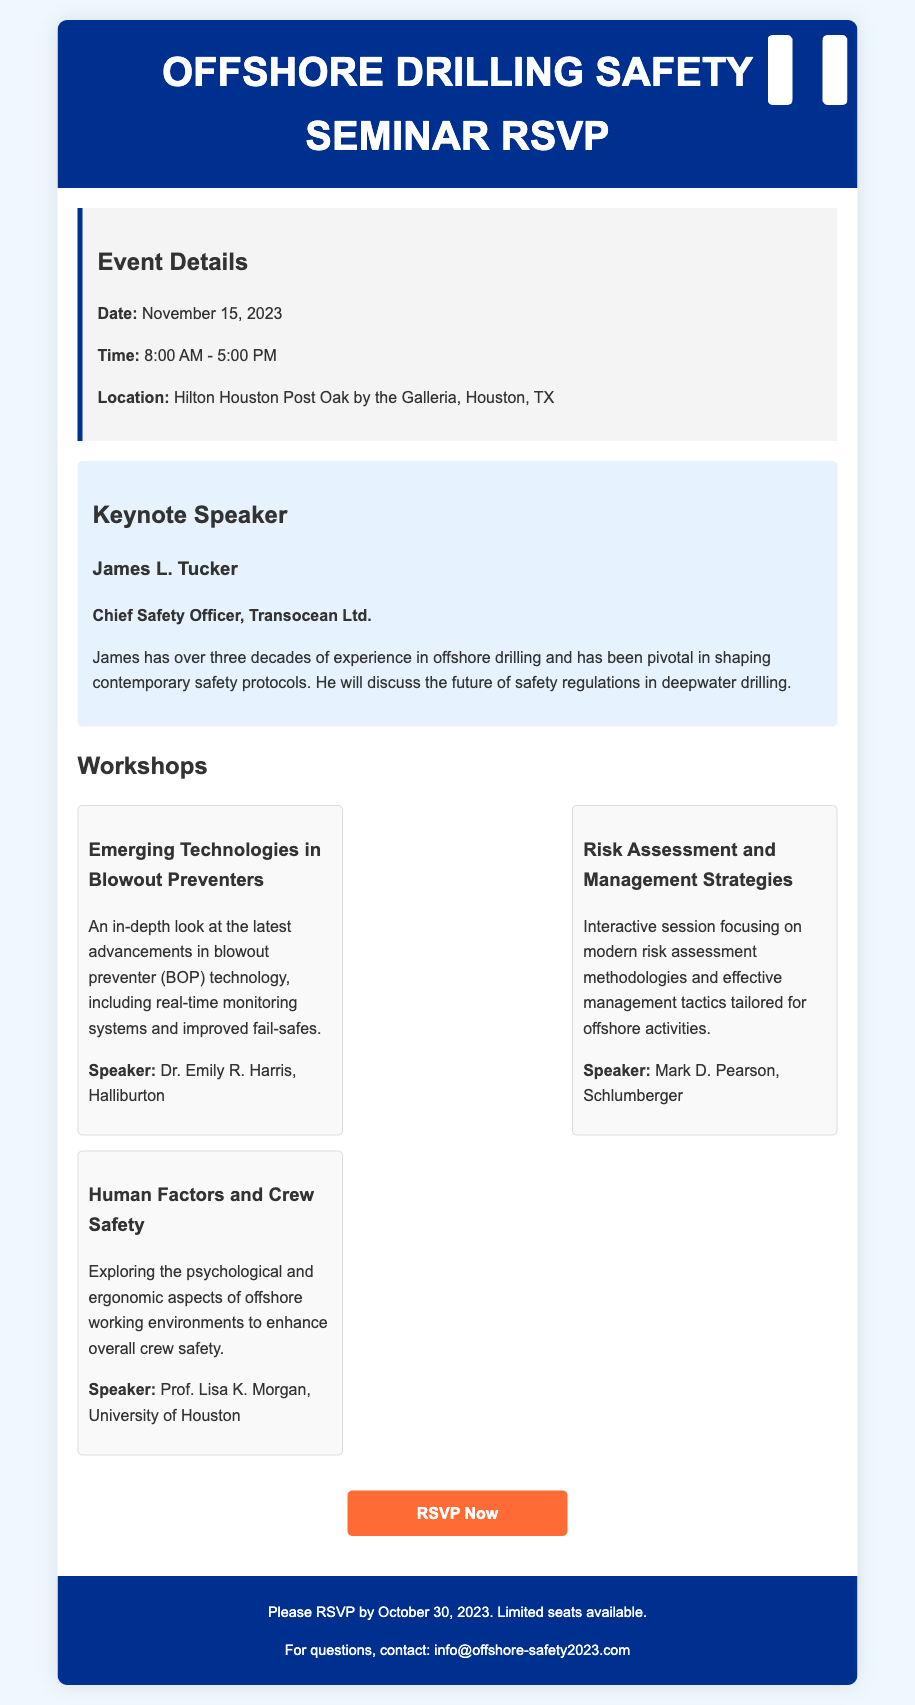What is the date of the seminar? The date of the seminar is explicitly stated in the event details section.
Answer: November 15, 2023 Who is the keynote speaker? The keynote speaker's name is listed under the keynote speaker section.
Answer: James L. Tucker What is James L. Tucker's position? His position is detailed alongside his name in the document.
Answer: Chief Safety Officer, Transocean Ltd How many workshops are listed? The number of workshops can be counted from the workshops section in the document.
Answer: Three What is the title of the workshop led by Dr. Emily R. Harris? The workshop titles are specified within the workshops section.
Answer: Emerging Technologies in Blowout Preventers What time does the seminar start? The starting time is noted in the event details section of the document.
Answer: 8:00 AM What is the RSVP deadline? The RSVP deadline is mentioned in the footer of the document.
Answer: October 30, 2023 What is the location of the seminar? The location is provided in the event details section.
Answer: Hilton Houston Post Oak by the Galleria, Houston, TX Which company does Mark D. Pearson represent? The company name is found in the speaker details for the workshop he leads.
Answer: Schlumberger 